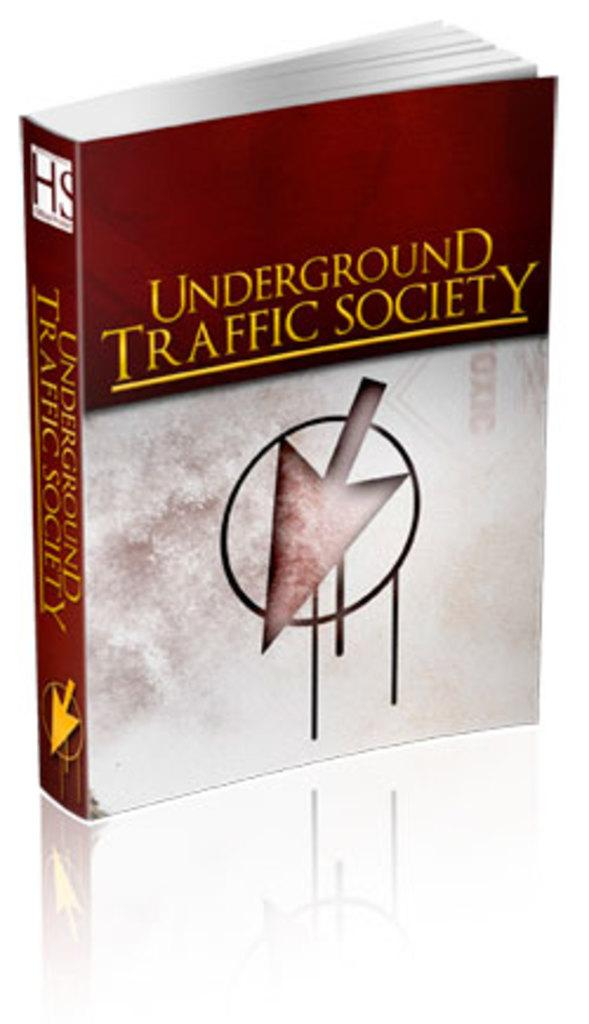<image>
Describe the image concisely. A book standing upright titled Underground Traffic Society. 